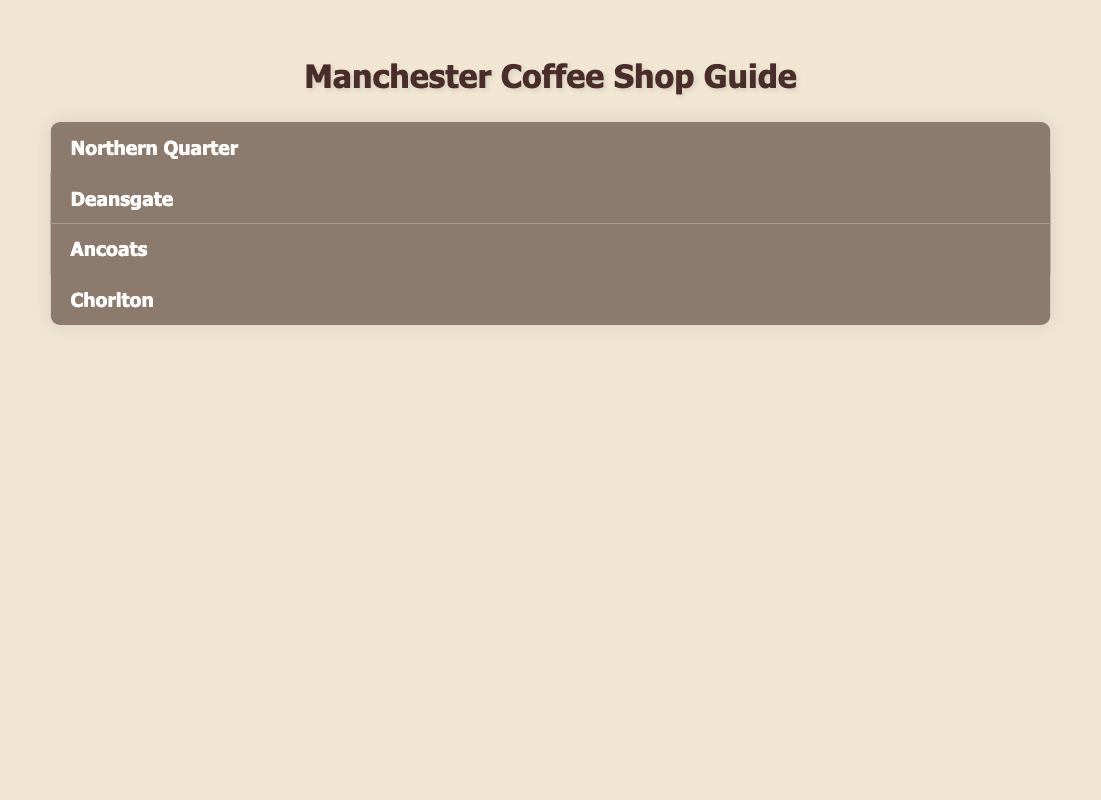What are the top-rated coffee shops in Manchester? The coffee shops with the highest ratings listed are Pollen Bakery with a rating of 4.8, Flat White at 4.7, and Chorlton Coffee also at 4.7.
Answer: Pollen Bakery, Flat White, Chorlton Coffee Which neighborhood has the coffee shop with the specialty of "Specialty Coffee"? The coffee shop that specializes in "Specialty Coffee" is Flat White, located in the Northern Quarter.
Answer: Northern Quarter How many coffee shops are located in the Deansgate neighborhood? There are two coffee shops listed in Deansgate: Costa Coffee and North Tea Power.
Answer: 2 Is Cafe Nerro rated higher than The Coffee Pot? Cafe Nerro has a rating of 4.4, which is lower than The Coffee Pot, which has a rating of 4.6. Therefore, Cafe Nerro is not rated higher.
Answer: No What is the average rating of the coffee shops in Chorlton? The ratings for Chorlton coffee shops are 4.6 for The Coffee Pot and 4.7 for Chorlton Coffee. The average rating is (4.6 + 4.7) / 2 = 4.65.
Answer: 4.65 Which coffee shop in Ancoats specializes in baked goods? Pollen Bakery specializes in baked goods and coffee, making it the relevant coffee shop in Ancoats.
Answer: Pollen Bakery Are there more coffee shops with a rating over 4.5 in the Northern Quarter than in Chorlton? In the Northern Quarter, both Flat White (4.7) and Takk (4.6) are over 4.5 (total 2), while in Chorlton, both The Coffee Pot (4.6) and Chorlton Coffee (4.7) are also over 4.5 (total 2). Therefore, the counts are equal.
Answer: No What neighborhood has the lowest rated coffee shop and what is the rating? The lowest rated coffee shop is Costa Coffee with a rating of 4.2, located in Deansgate.
Answer: Deansgate, 4.2 